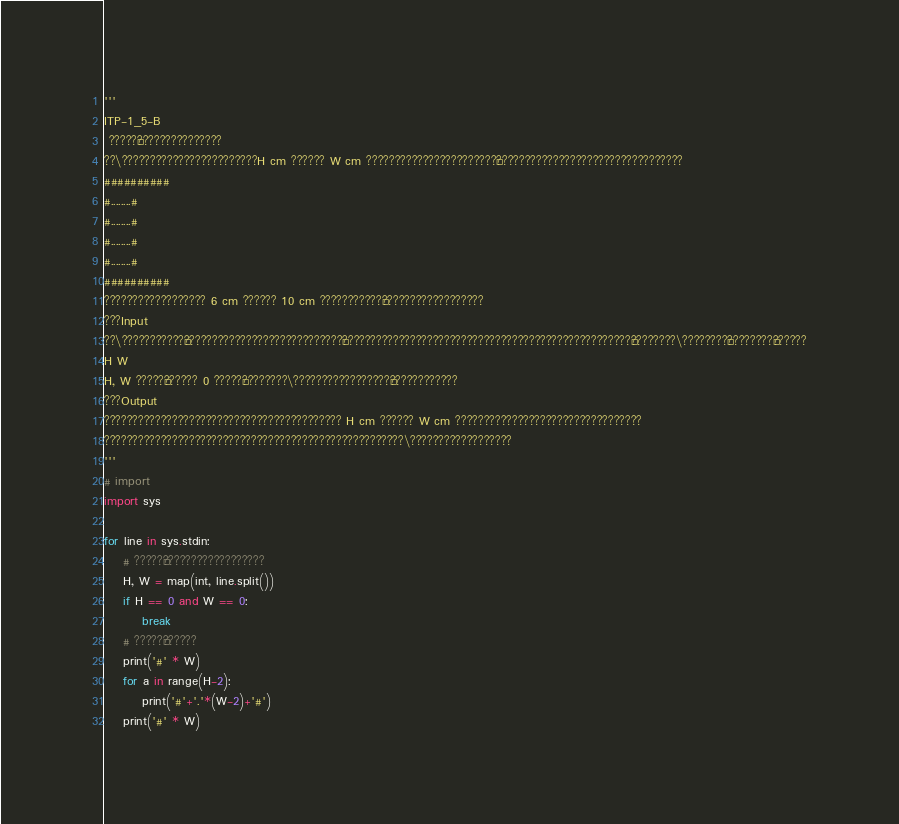<code> <loc_0><loc_0><loc_500><loc_500><_Python_>'''
ITP-1_5-B
 ?????¬???????????????
??\????????????????????????H cm ?????? W cm ???????????????????????°?????????????????????????????????
##########
#........#
#........#
#........#
#........#
##########
?????????????????? 6 cm ?????? 10 cm ???????????¨??????????????????
???Input
??\???????????°????????????????????????????§???????????????????????????????????????????????????¢????????\????????¨????????§??????
H W
H, W ?????¨?????? 0 ?????¨????????\?????????????????¨????????????
???Output
?????????????????????????????????????????? H cm ?????? W cm ?????????????????????????????????
?????????????????????????????????????????????????????\??????????????????
'''
# import
import sys

for line in sys.stdin:
    # ?????°??????????????????
    H, W = map(int, line.split())
    if H == 0 and W == 0:
        break
    # ?????¢??????
    print('#' * W)
    for a in range(H-2):
        print('#'+'.'*(W-2)+'#')
    print('#' * W)</code> 